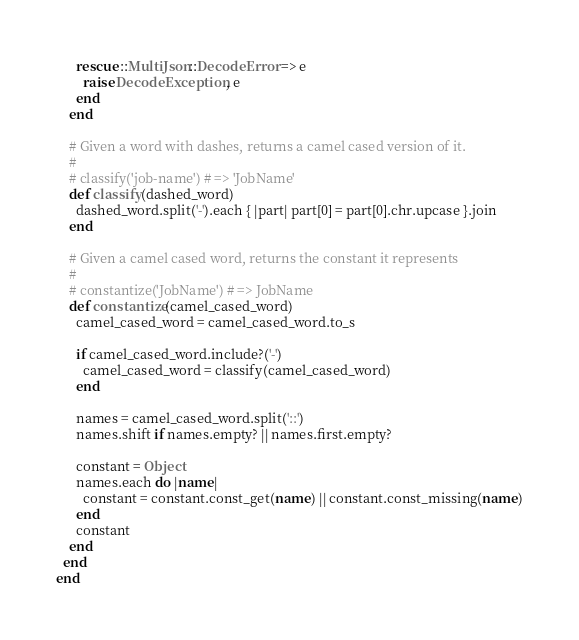Convert code to text. <code><loc_0><loc_0><loc_500><loc_500><_Ruby_>      rescue ::MultiJson::DecodeError => e
        raise DecodeException, e
      end
    end

    # Given a word with dashes, returns a camel cased version of it.
    #
    # classify('job-name') # => 'JobName'
    def classify(dashed_word)
      dashed_word.split('-').each { |part| part[0] = part[0].chr.upcase }.join
    end

    # Given a camel cased word, returns the constant it represents
    #
    # constantize('JobName') # => JobName
    def constantize(camel_cased_word)
      camel_cased_word = camel_cased_word.to_s

      if camel_cased_word.include?('-')
        camel_cased_word = classify(camel_cased_word)
      end

      names = camel_cased_word.split('::')
      names.shift if names.empty? || names.first.empty?

      constant = Object
      names.each do |name|
        constant = constant.const_get(name) || constant.const_missing(name)
      end
      constant
    end
  end
end
</code> 